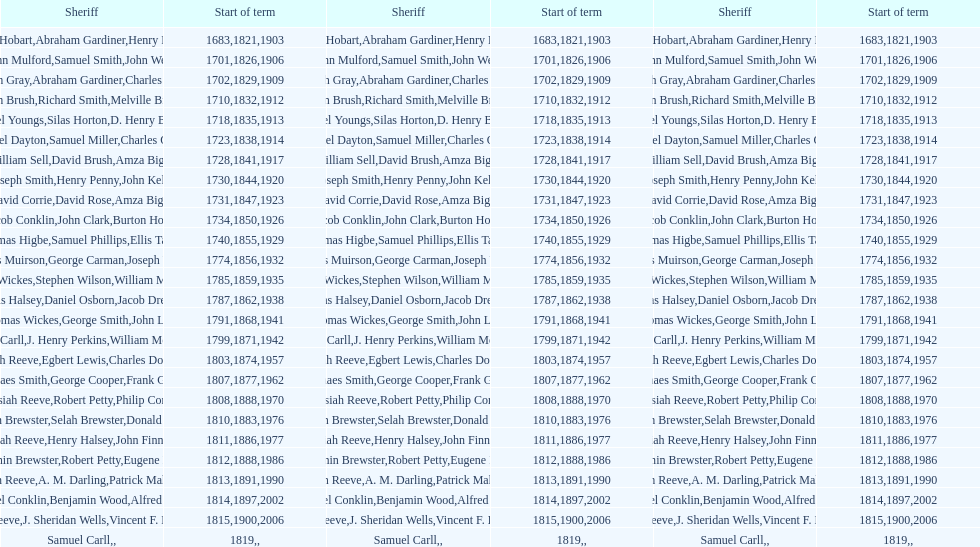What is the number of sheriff's with the last name smith? 5. 